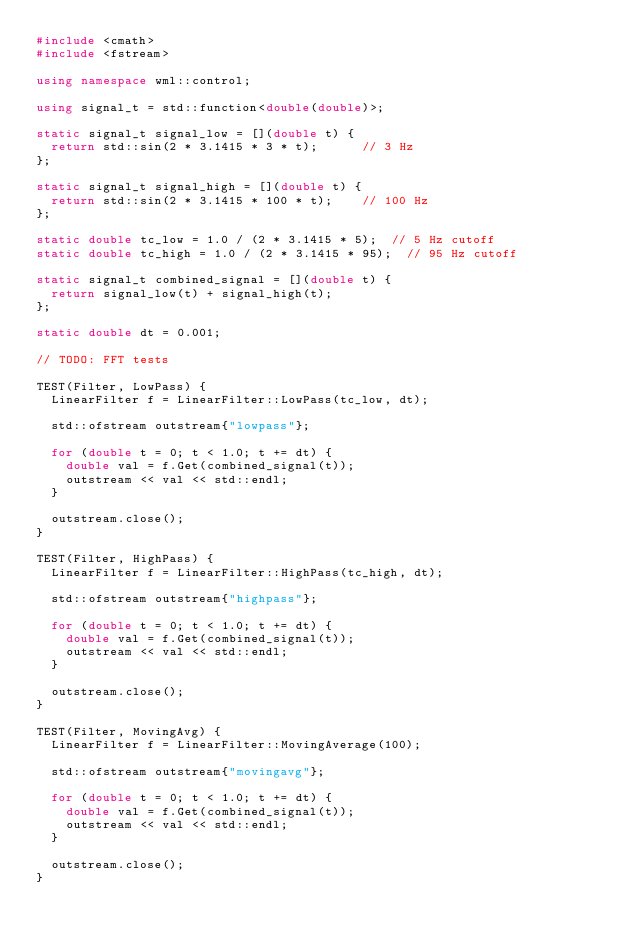<code> <loc_0><loc_0><loc_500><loc_500><_C++_>#include <cmath>
#include <fstream>

using namespace wml::control;

using signal_t = std::function<double(double)>;

static signal_t signal_low = [](double t) {
  return std::sin(2 * 3.1415 * 3 * t);      // 3 Hz
};

static signal_t signal_high = [](double t) {
  return std::sin(2 * 3.1415 * 100 * t);    // 100 Hz
};

static double tc_low = 1.0 / (2 * 3.1415 * 5);  // 5 Hz cutoff
static double tc_high = 1.0 / (2 * 3.1415 * 95);  // 95 Hz cutoff

static signal_t combined_signal = [](double t) {
  return signal_low(t) + signal_high(t);
};

static double dt = 0.001;

// TODO: FFT tests

TEST(Filter, LowPass) {
  LinearFilter f = LinearFilter::LowPass(tc_low, dt);
  
  std::ofstream outstream{"lowpass"};

  for (double t = 0; t < 1.0; t += dt) {
    double val = f.Get(combined_signal(t));
    outstream << val << std::endl;
  }

  outstream.close();
}

TEST(Filter, HighPass) {
  LinearFilter f = LinearFilter::HighPass(tc_high, dt);
  
  std::ofstream outstream{"highpass"};

  for (double t = 0; t < 1.0; t += dt) {
    double val = f.Get(combined_signal(t));
    outstream << val << std::endl;
  }

  outstream.close();
}

TEST(Filter, MovingAvg) {
  LinearFilter f = LinearFilter::MovingAverage(100);
  
  std::ofstream outstream{"movingavg"};

  for (double t = 0; t < 1.0; t += dt) {
    double val = f.Get(combined_signal(t));
    outstream << val << std::endl;
  }

  outstream.close();
}</code> 